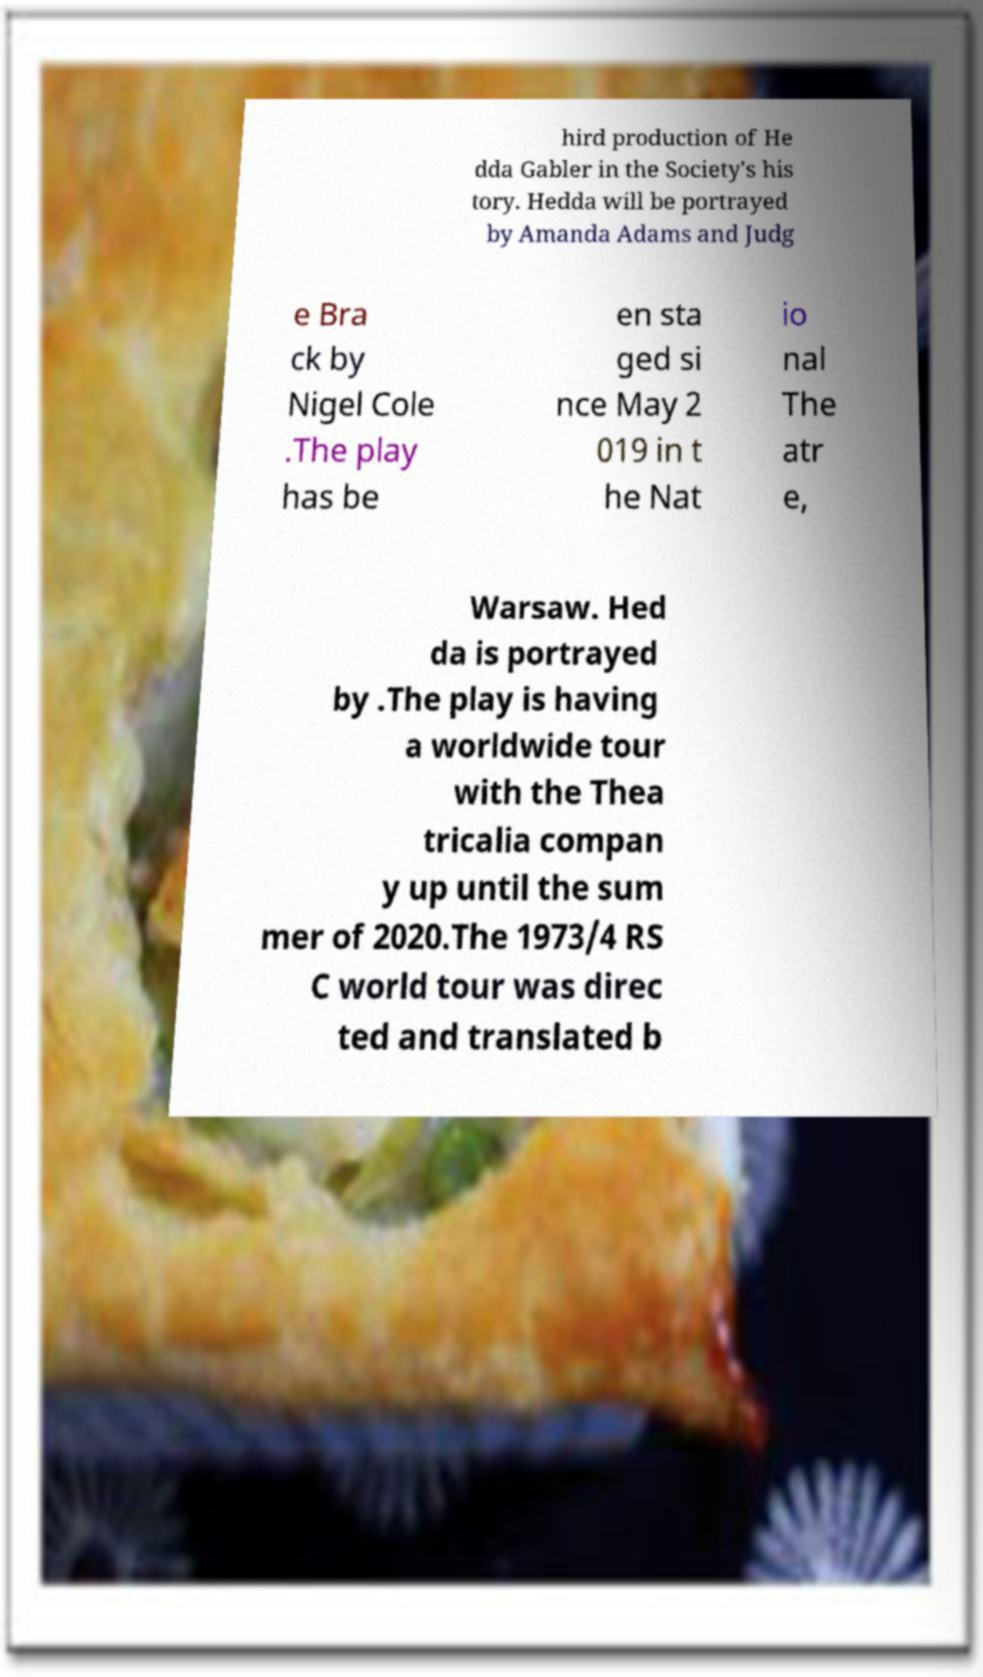Please identify and transcribe the text found in this image. hird production of He dda Gabler in the Society's his tory. Hedda will be portrayed by Amanda Adams and Judg e Bra ck by Nigel Cole .The play has be en sta ged si nce May 2 019 in t he Nat io nal The atr e, Warsaw. Hed da is portrayed by .The play is having a worldwide tour with the Thea tricalia compan y up until the sum mer of 2020.The 1973/4 RS C world tour was direc ted and translated b 